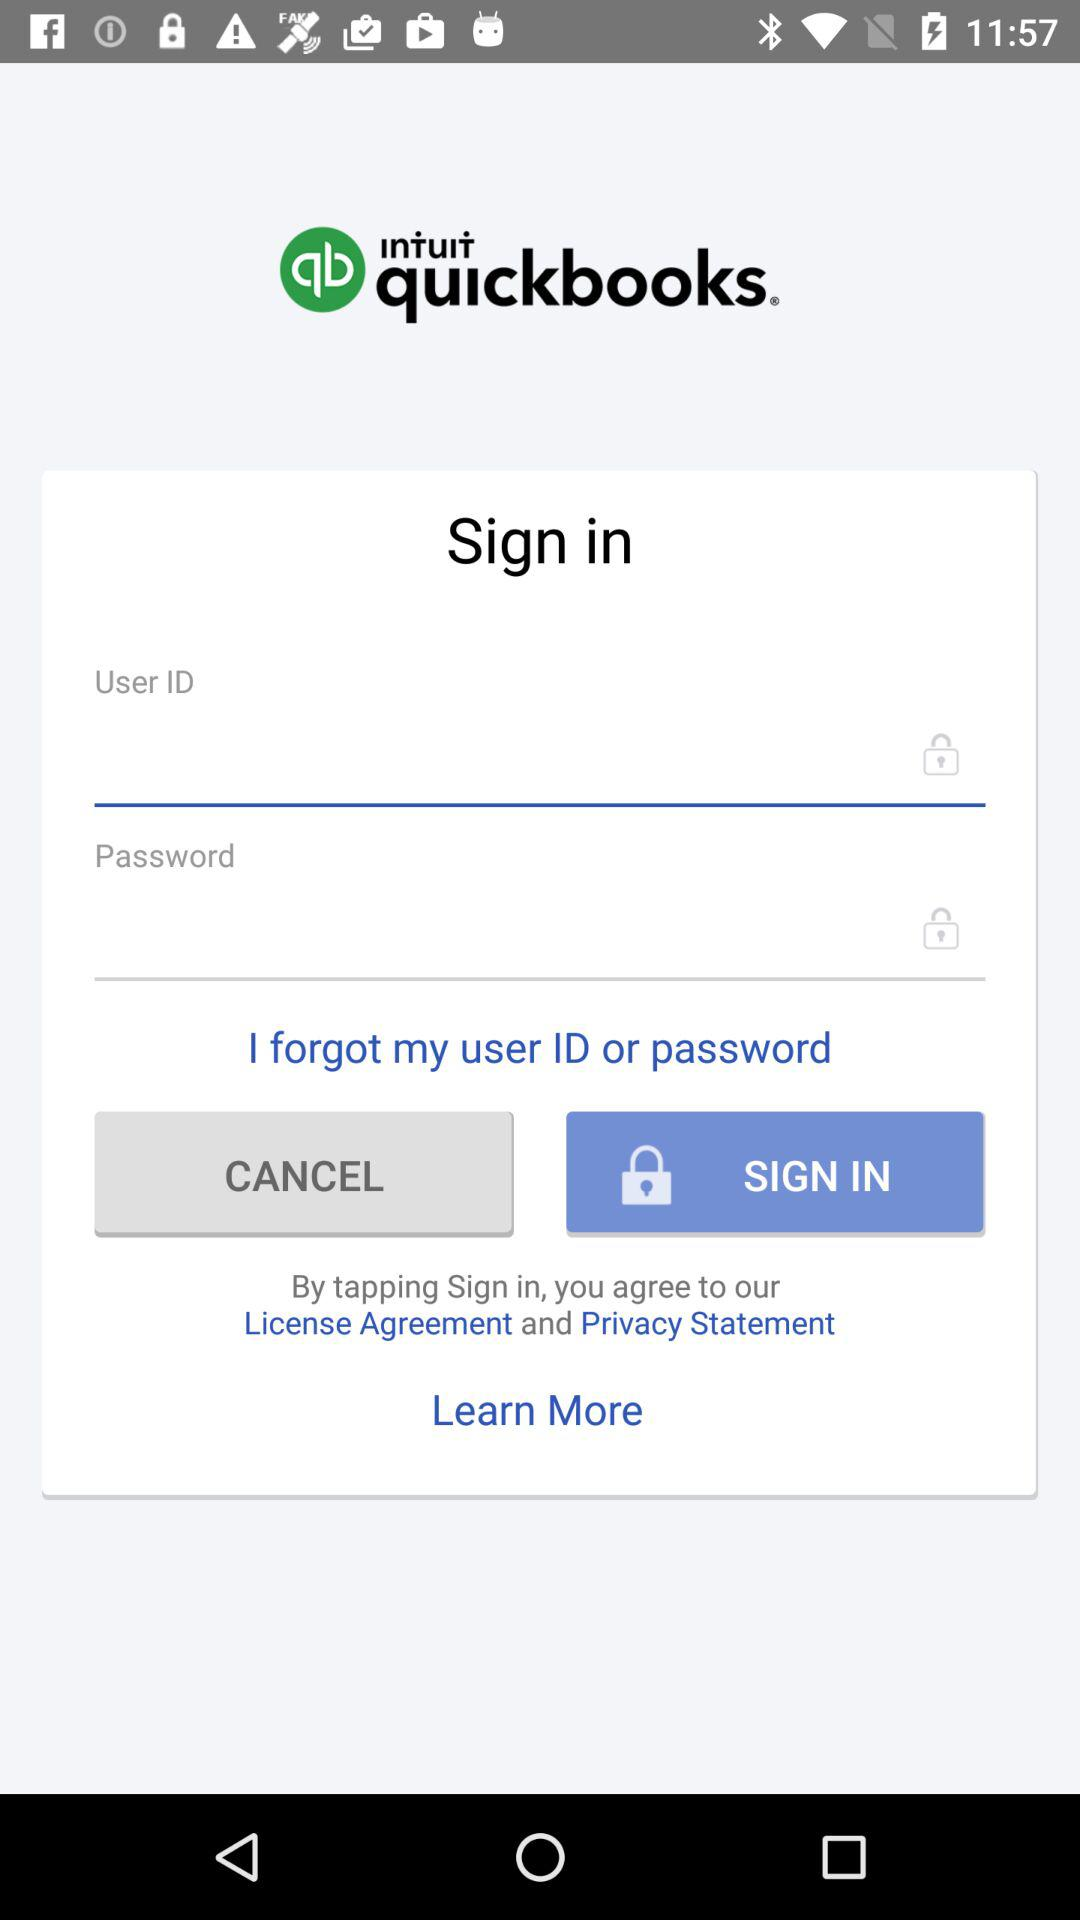What is the name of the application? The name of the application is "INTUIT quickbooks". 